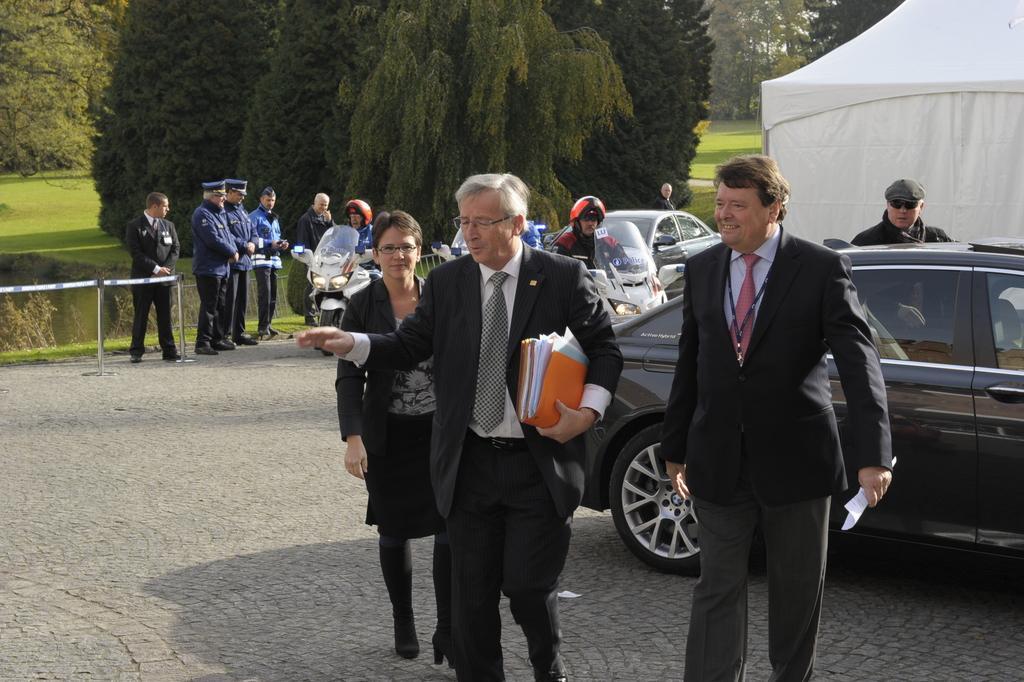In one or two sentences, can you explain what this image depicts? This picture describes about group of people, in the middle of the image we can see a man, he wore spectacles and he is holding files, in the background we can see few vehicles, tent and trees, and also we can find few people are seated on the motorcycles. 